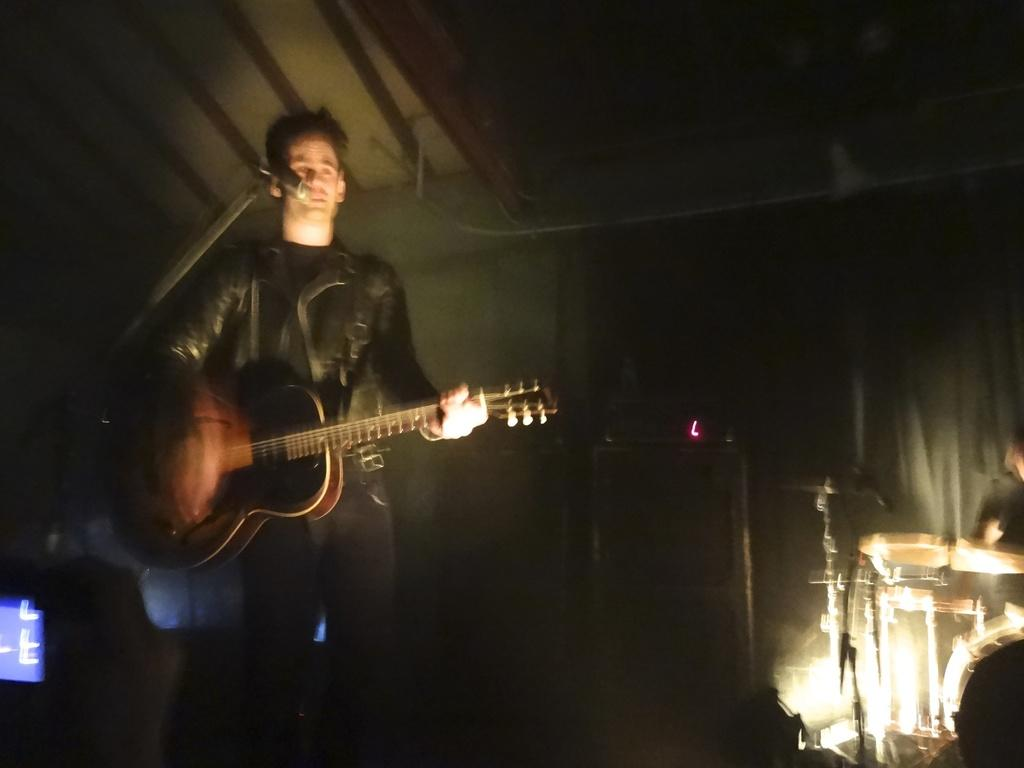What is the main subject of the image? The main subject of the image is a man. What is the man doing in the image? The man is standing and playing a guitar. What object is in front of the man? There is a microphone in front of the man. What type of yoke is the man using to play the guitar in the image? There is no yoke present in the image, and the man is not using any yoke to play the guitar. What type of dress is the man wearing in the image? The image does not show the man wearing a dress; he is wearing clothing appropriate for playing the guitar. 